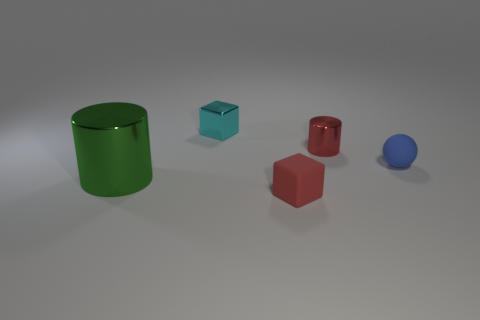Subtract all green cylinders. How many cylinders are left? 1 Add 4 tiny cyan blocks. How many objects exist? 9 Subtract 0 cyan spheres. How many objects are left? 5 Subtract all balls. How many objects are left? 4 Subtract 1 blocks. How many blocks are left? 1 Subtract all cyan blocks. Subtract all green spheres. How many blocks are left? 1 Subtract all blue balls. How many green cylinders are left? 1 Subtract all tiny cyan objects. Subtract all large balls. How many objects are left? 4 Add 1 tiny red cylinders. How many tiny red cylinders are left? 2 Add 2 large purple cubes. How many large purple cubes exist? 2 